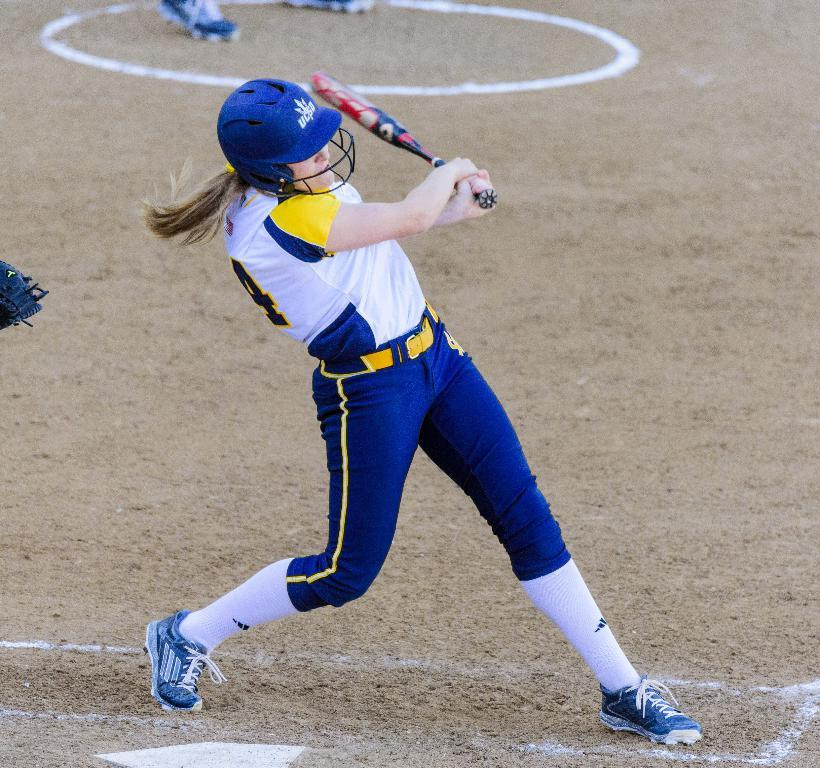Who or what is present in the image? There is a person in the image. What is the person doing in the image? The person is standing on the ground and holding a baseball bat. Can you describe any other objects or features in the image? There is a helmet visible in the background of the image. What part of the person's body can be seen in the image? The person's leg is visible in the image. What type of liquid is being poured out of the baseball bat in the image? There is no liquid being poured out of the baseball bat in the image; it is a solid object used for hitting a ball. 